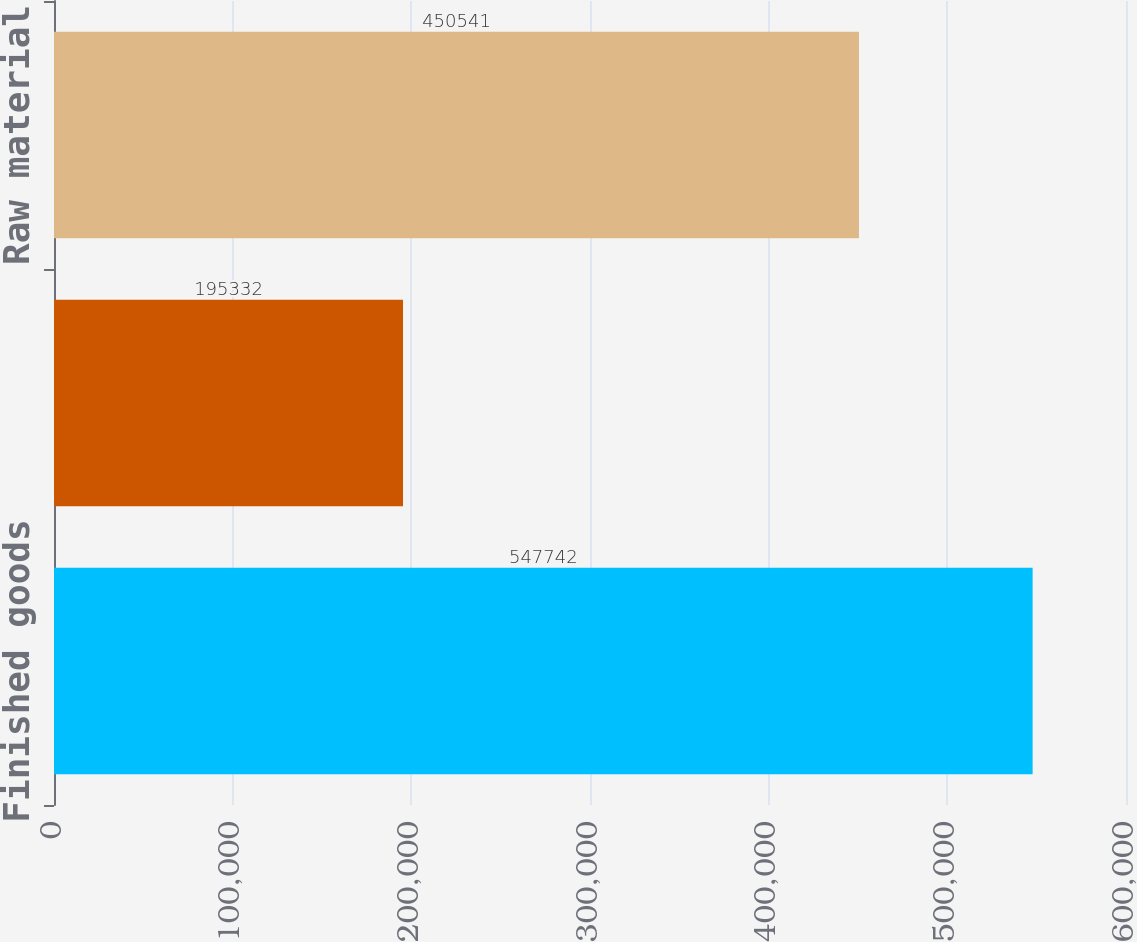Convert chart to OTSL. <chart><loc_0><loc_0><loc_500><loc_500><bar_chart><fcel>Finished goods<fcel>Work in process<fcel>Raw material<nl><fcel>547742<fcel>195332<fcel>450541<nl></chart> 